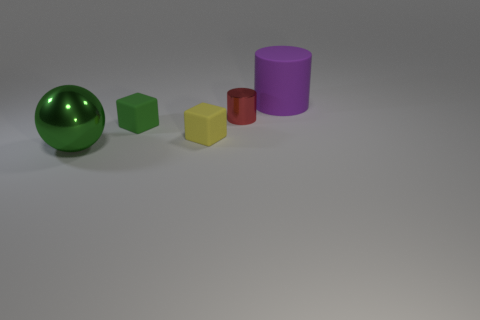Subtract 1 purple cylinders. How many objects are left? 4 Subtract all balls. How many objects are left? 4 Subtract 1 cubes. How many cubes are left? 1 Subtract all cyan balls. Subtract all gray blocks. How many balls are left? 1 Subtract all yellow spheres. How many brown cylinders are left? 0 Subtract all purple metallic cubes. Subtract all purple things. How many objects are left? 4 Add 5 shiny spheres. How many shiny spheres are left? 6 Add 3 tiny purple balls. How many tiny purple balls exist? 3 Add 4 big green metallic spheres. How many objects exist? 9 Subtract all red cylinders. How many cylinders are left? 1 